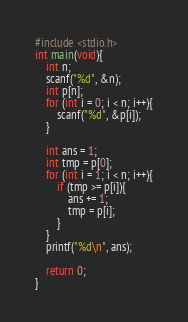<code> <loc_0><loc_0><loc_500><loc_500><_C_>#include <stdio.h>
int main(void){
    int n;
    scanf("%d", &n);
    int p[n];
    for (int i = 0; i < n; i++){
        scanf("%d", &p[i]);
    }

    int ans = 1;
    int tmp = p[0];
    for (int i = 1; i < n; i++){
        if (tmp >= p[i]){
            ans += 1;
            tmp = p[i];
        }
    }
    printf("%d\n", ans);

    return 0;
}
</code> 